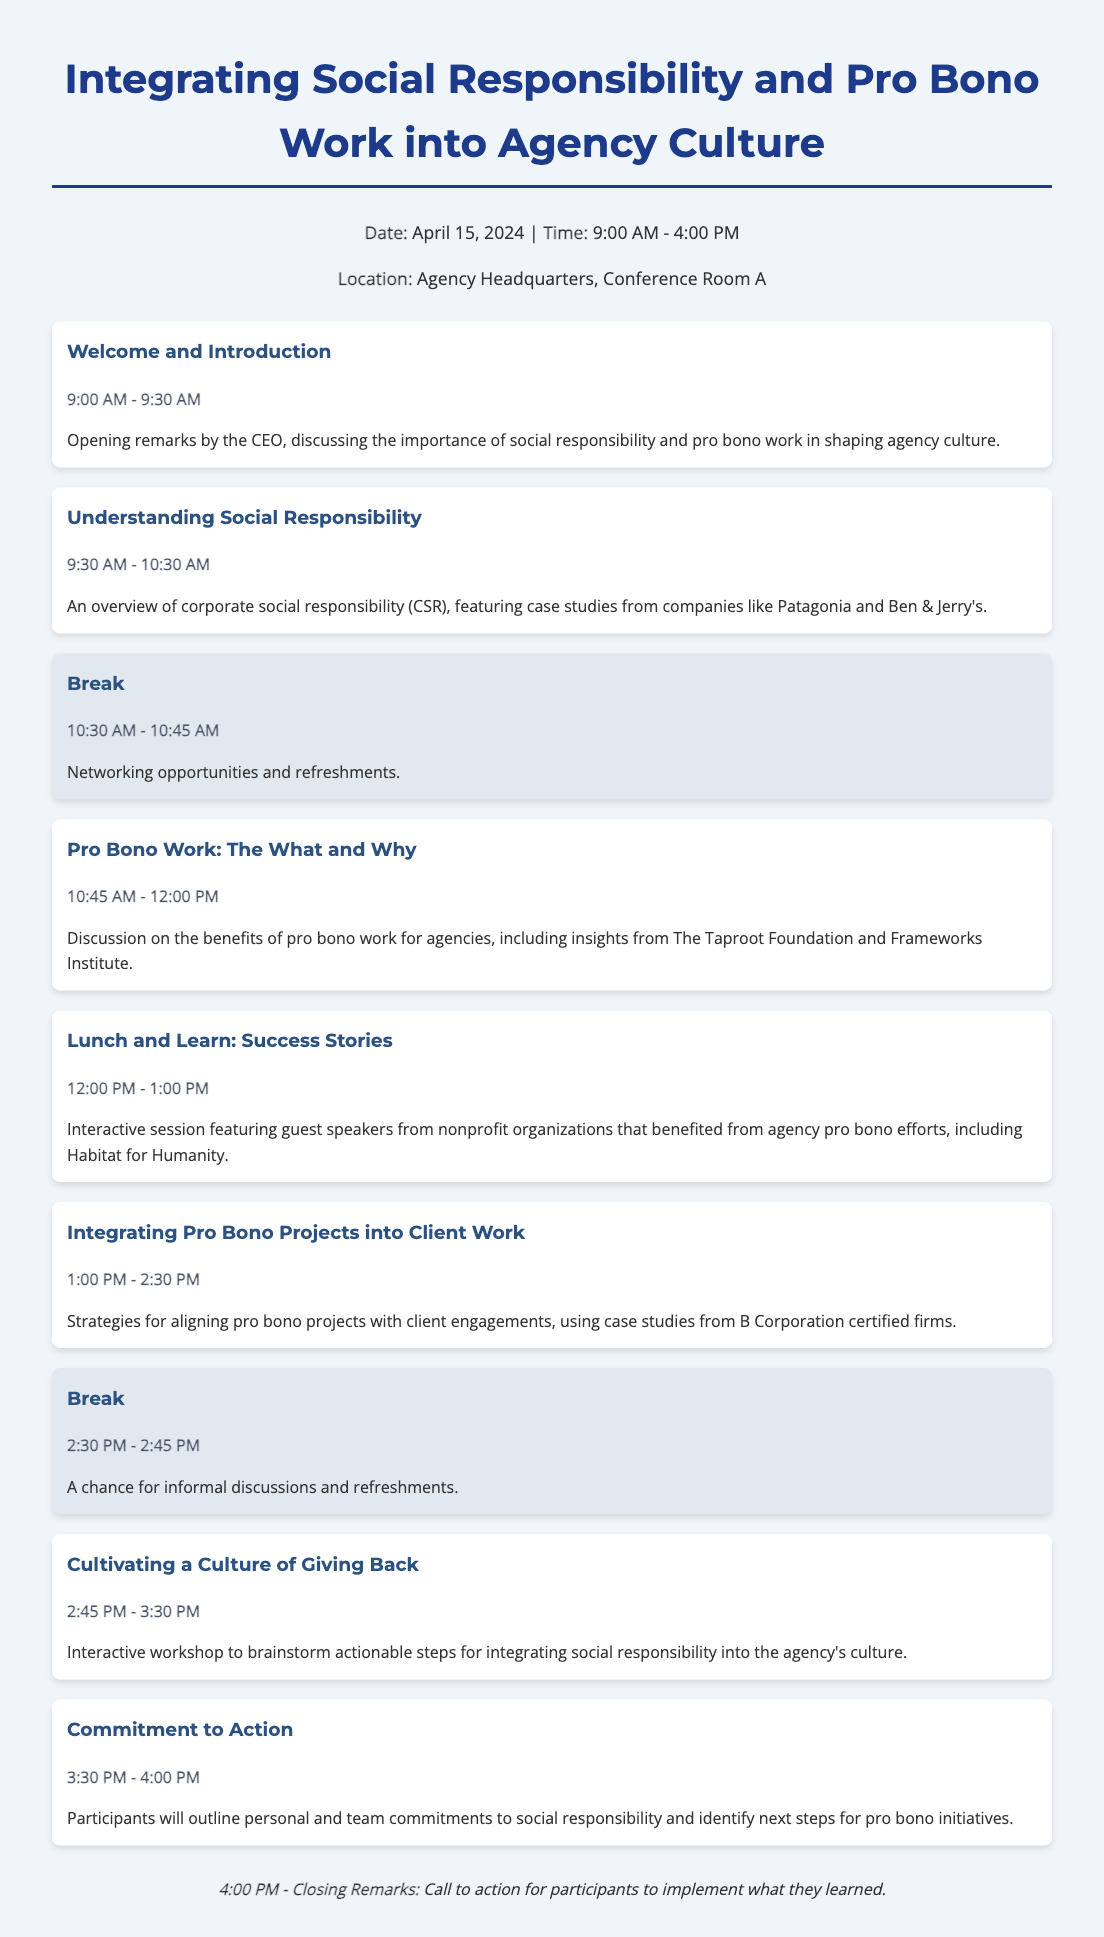what is the date of the workshop? The date of the workshop is explicitly mentioned at the top of the document.
Answer: April 15, 2024 what time does the workshop start? The starting time is indicated in the header of the agenda.
Answer: 9:00 AM who is giving the opening remarks? The document states that the opening remarks will be given by a specific role.
Answer: CEO what is the topic of the session at 10:45 AM? The agenda lists the title of the session scheduled for that time.
Answer: Pro Bono Work: The What and Why how long is the break after the second session? The duration of the break is stated right above the break section.
Answer: 15 minutes what is discussed in the "Lunch and Learn" session? The topic covered during the lunch session is described in the agenda item.
Answer: Success Stories what is the focus of the final session at 3:30 PM? The content of the last item in the agenda outlines the purpose of that session.
Answer: Commitment to Action how many guest speakers participate in the "Lunch and Learn"? The number of guest speakers is implied within the description of the session.
Answer: Multiple what are participants expected to outline in the "Commitment to Action" session? The expectations from the participants in the final session are summarized in the agenda.
Answer: personal and team commitments 